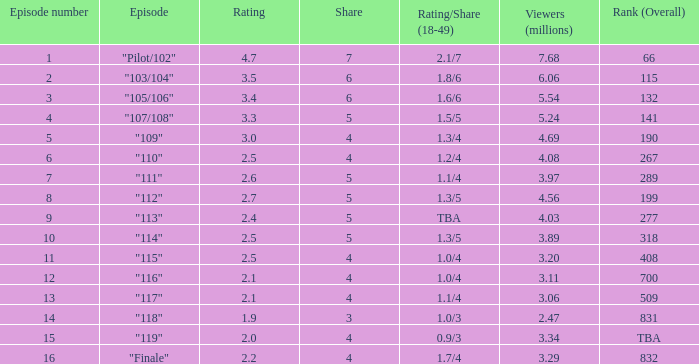What is the quantity of audience with more than 10 episodes and ratings below 2? 2.47. 